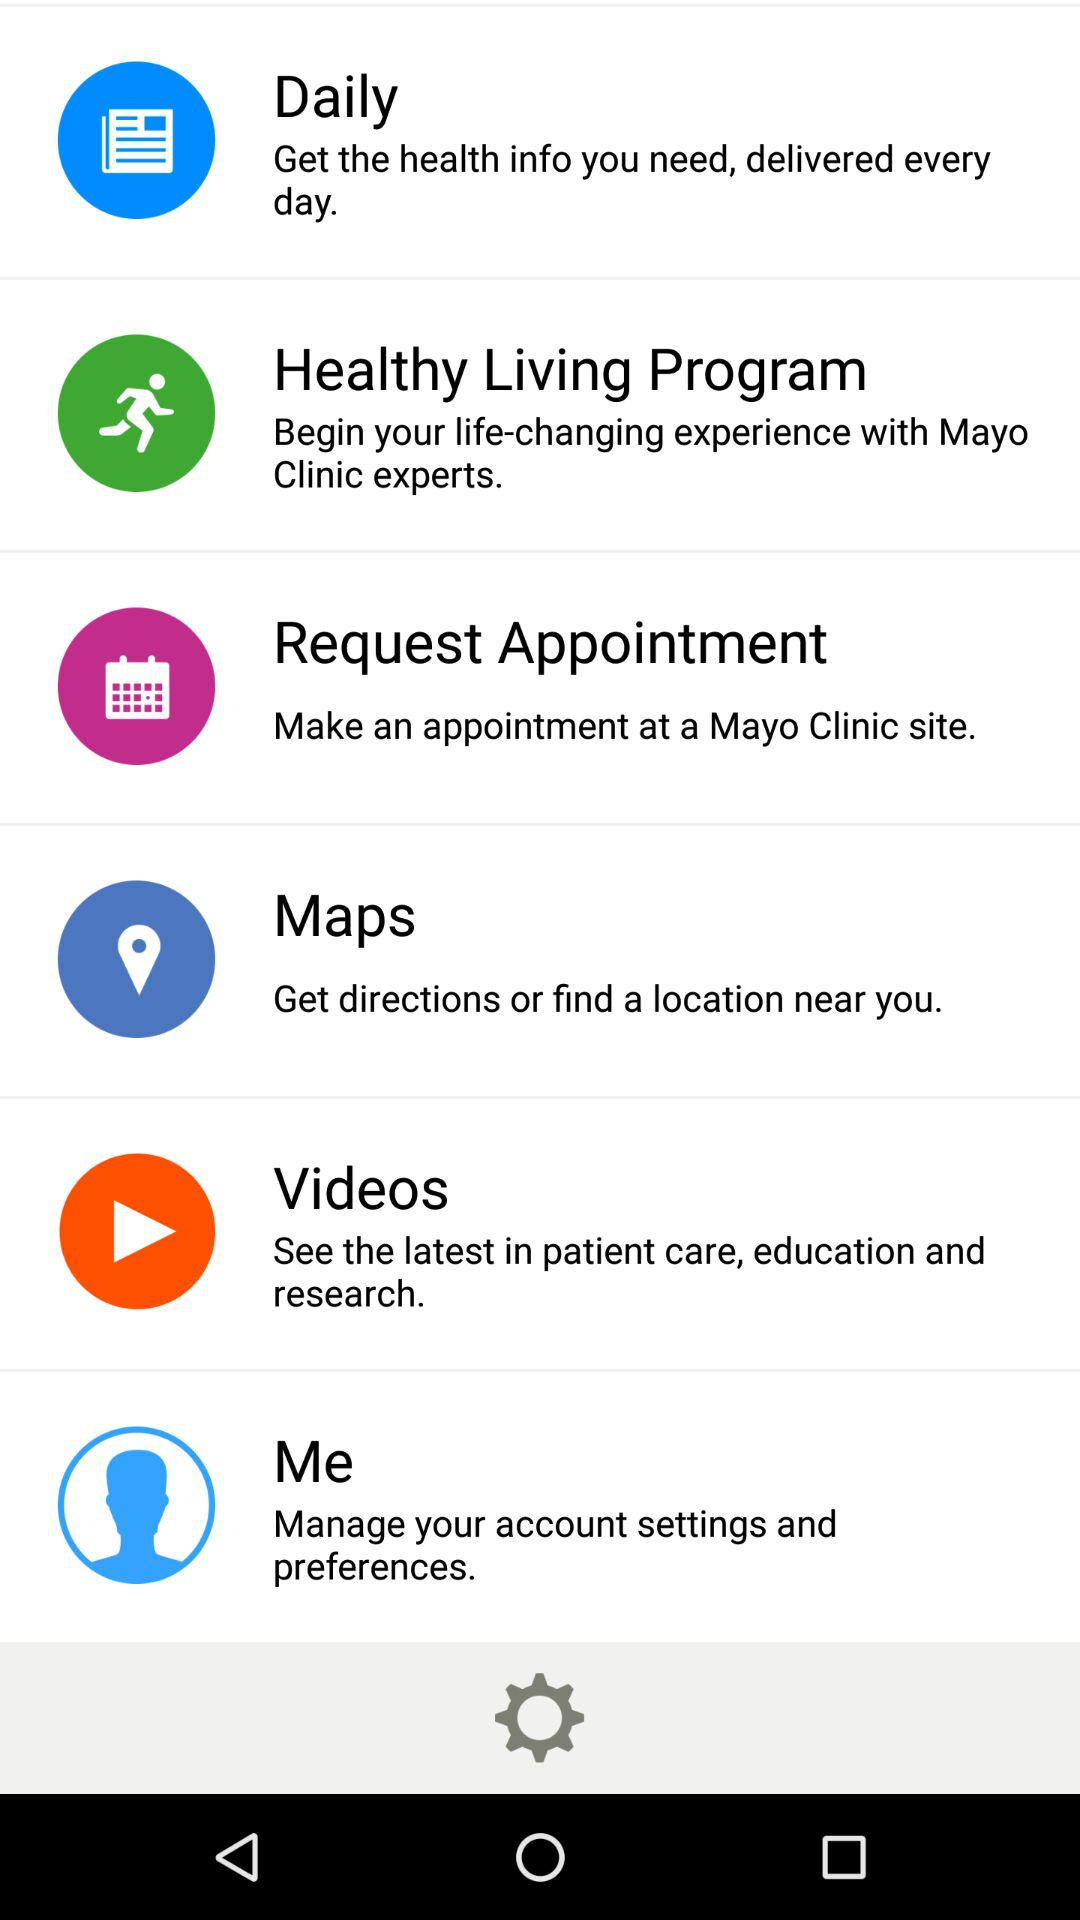From which option can we make an appointment at a Mayo Clinic site? You can make an appointment at a Mayo Clinic site from the "Request Appointment" option. 